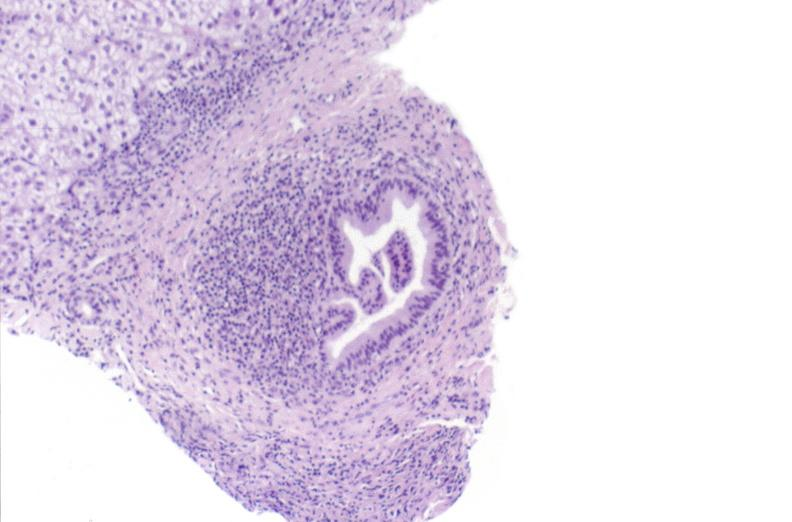s metastatic carcinoma breast present?
Answer the question using a single word or phrase. No 